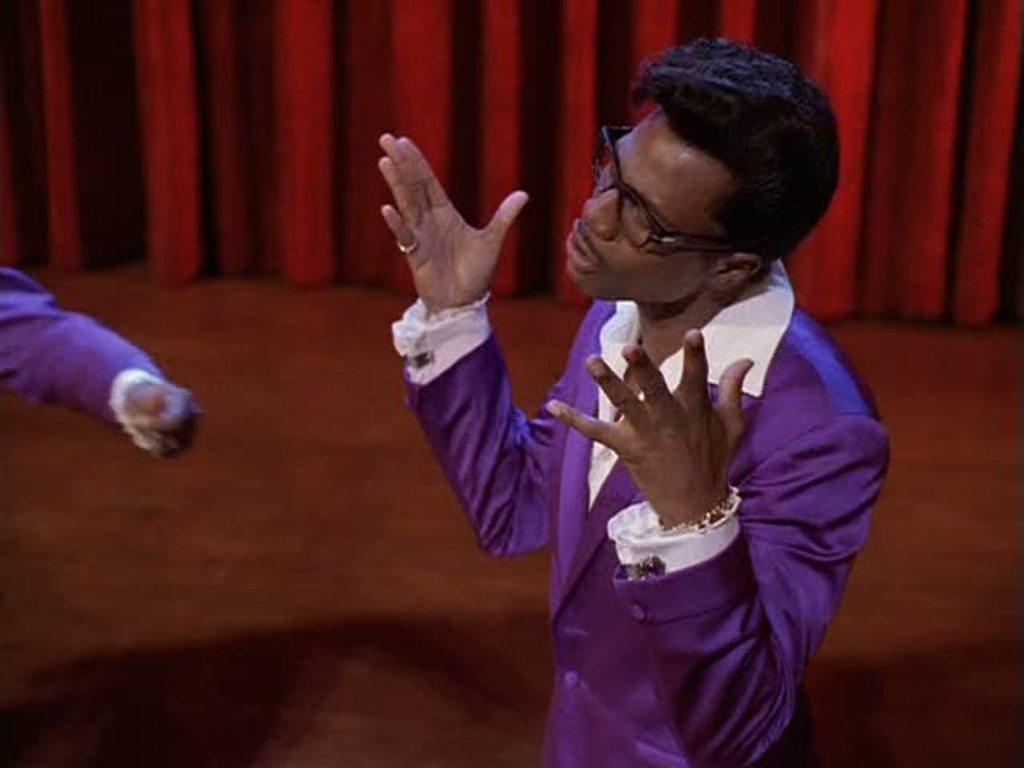What is the person in the image wearing on their face? The person in the image is wearing spectacles. What is the position of the person in the image? The person is standing. How many people are in the image? There are two people in the image. What part of the second person's body is visible? The second person's hand is visible. What can be seen hanging in the background of the image? There is a red color curtain hanging in the background. What type of debt is the person in the image discussing with the second person? There is no indication of any debt or discussion about debt in the image. 